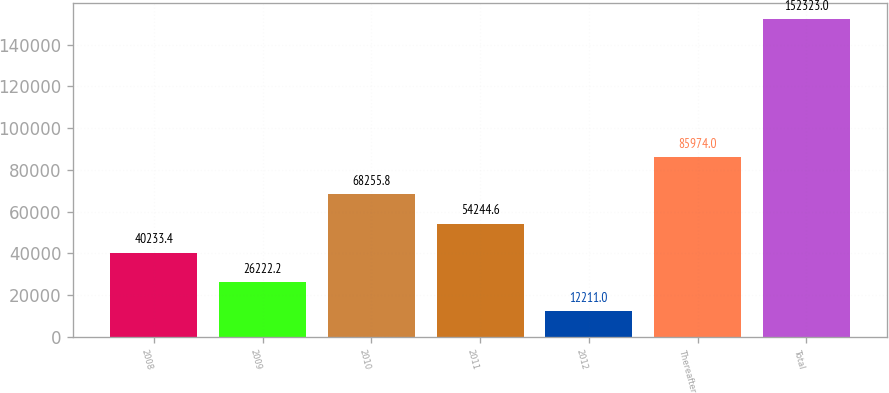Convert chart to OTSL. <chart><loc_0><loc_0><loc_500><loc_500><bar_chart><fcel>2008<fcel>2009<fcel>2010<fcel>2011<fcel>2012<fcel>Thereafter<fcel>Total<nl><fcel>40233.4<fcel>26222.2<fcel>68255.8<fcel>54244.6<fcel>12211<fcel>85974<fcel>152323<nl></chart> 